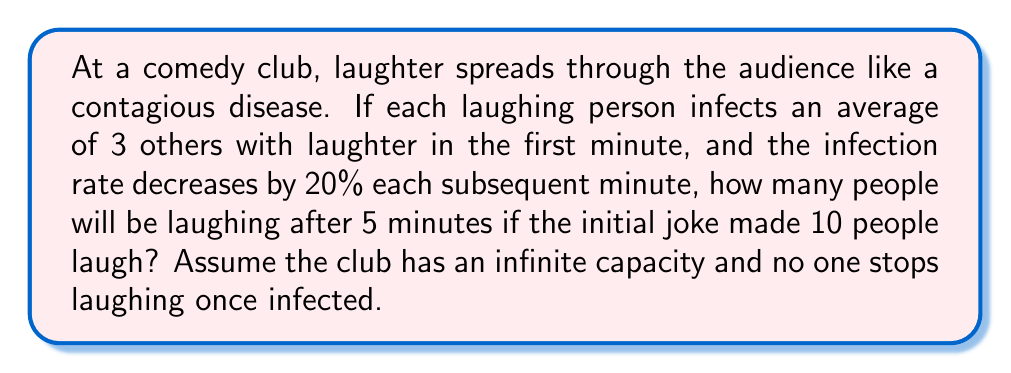Show me your answer to this math problem. Let's approach this problem using a simplified epidemic model:

1) Initial conditions:
   - $I_0 = 10$ (initial infected/laughing people)
   - $R_0 = 3$ (initial reproduction number)
   - Decay rate = 20% = 0.2 per minute

2) Calculate the reproduction number for each minute:
   $R_t = R_0 * (1 - 0.2)^t$, where $t$ is the minute number
   
   Minute 1: $R_1 = 3 * (1 - 0.2)^1 = 2.4$
   Minute 2: $R_2 = 3 * (1 - 0.2)^2 = 1.92$
   Minute 3: $R_3 = 3 * (1 - 0.2)^3 = 1.536$
   Minute 4: $R_4 = 3 * (1 - 0.2)^4 = 1.2288$
   Minute 5: $R_5 = 3 * (1 - 0.2)^5 = 0.98304$

3) Calculate new infections for each minute:
   Minute 1: $10 * 2.4 = 24$ new infections
   Minute 2: $24 * 1.92 = 46.08$ new infections
   Minute 3: $46.08 * 1.536 = 70.77$ new infections
   Minute 4: $70.77 * 1.2288 = 86.96$ new infections
   Minute 5: $86.96 * 0.98304 = 85.49$ new infections

4) Sum up all infections:
   Total = Initial + Sum of new infections
   $$ 10 + 24 + 46.08 + 70.77 + 86.96 + 85.49 = 323.30 $$

5) Since we're dealing with whole people, we round down to the nearest integer.
Answer: 323 people will be laughing after 5 minutes. 